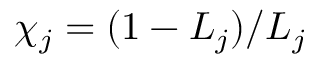Convert formula to latex. <formula><loc_0><loc_0><loc_500><loc_500>\chi _ { j } = ( 1 - L _ { j } ) / L _ { j }</formula> 